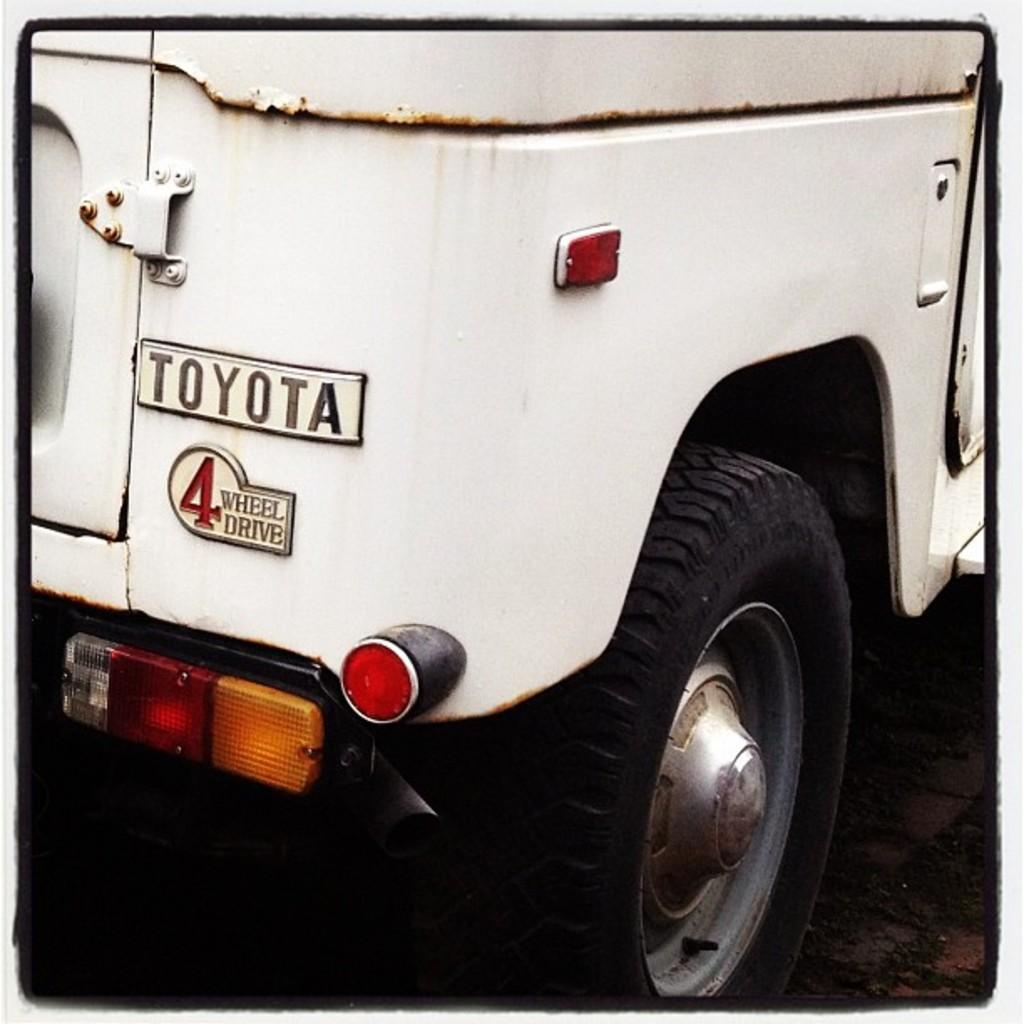What type of object is present in the image? There is a part of a motor vehicle in the image. Where is the motor vehicle part located? The motor vehicle part is placed on the ground. What historical event is depicted in the image involving the motor vehicle part? There is no historical event depicted in the image; it simply shows a part of a motor vehicle placed on the ground. 